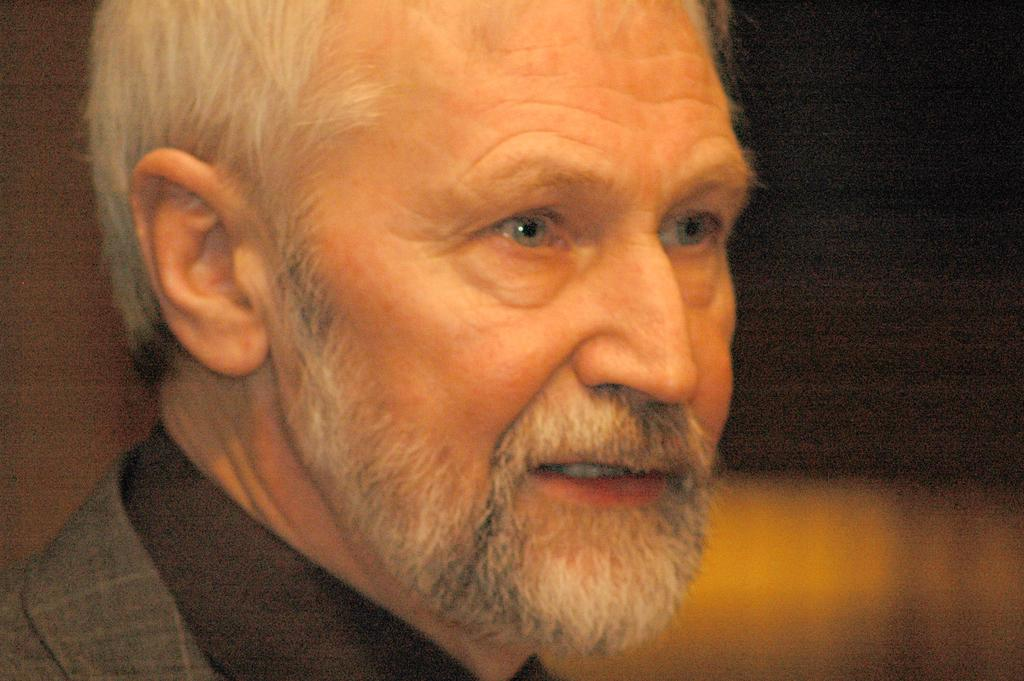What is present in the image? There is a person in the image. What direction is the person looking in? The person is looking to the right side of the image. What type of knee can be seen in the image? There is no knee visible in the image; only a person is present. 